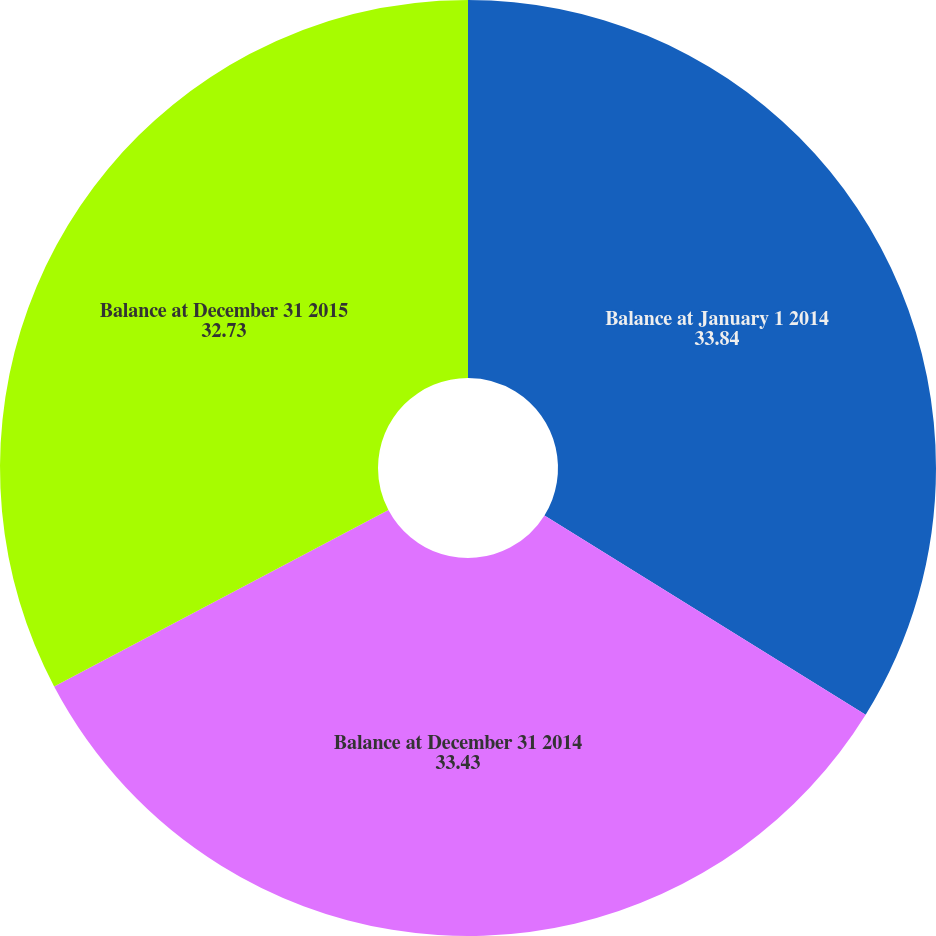Convert chart to OTSL. <chart><loc_0><loc_0><loc_500><loc_500><pie_chart><fcel>Balance at January 1 2014<fcel>Balance at December 31 2014<fcel>Balance at December 31 2015<nl><fcel>33.84%<fcel>33.43%<fcel>32.73%<nl></chart> 